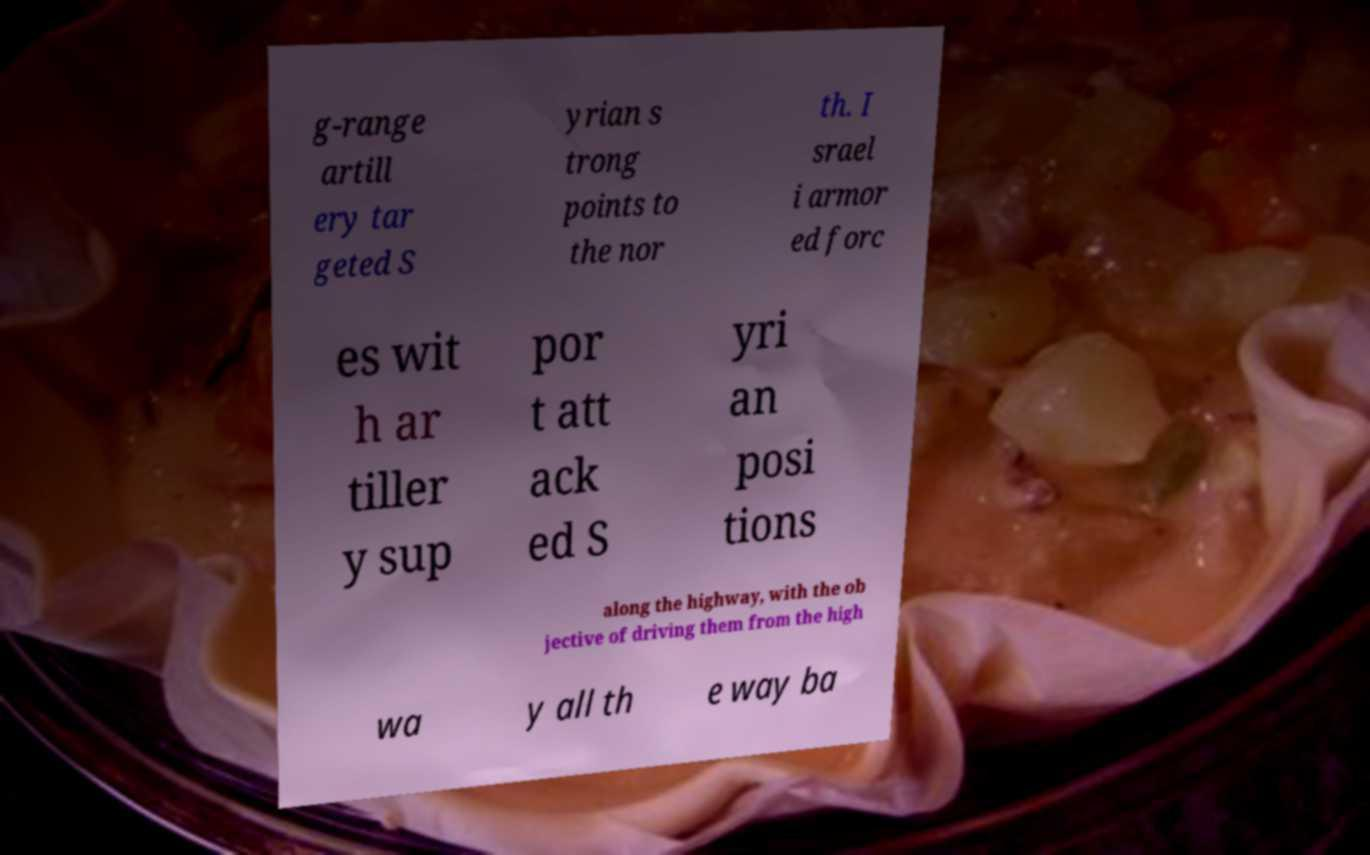Could you extract and type out the text from this image? g-range artill ery tar geted S yrian s trong points to the nor th. I srael i armor ed forc es wit h ar tiller y sup por t att ack ed S yri an posi tions along the highway, with the ob jective of driving them from the high wa y all th e way ba 